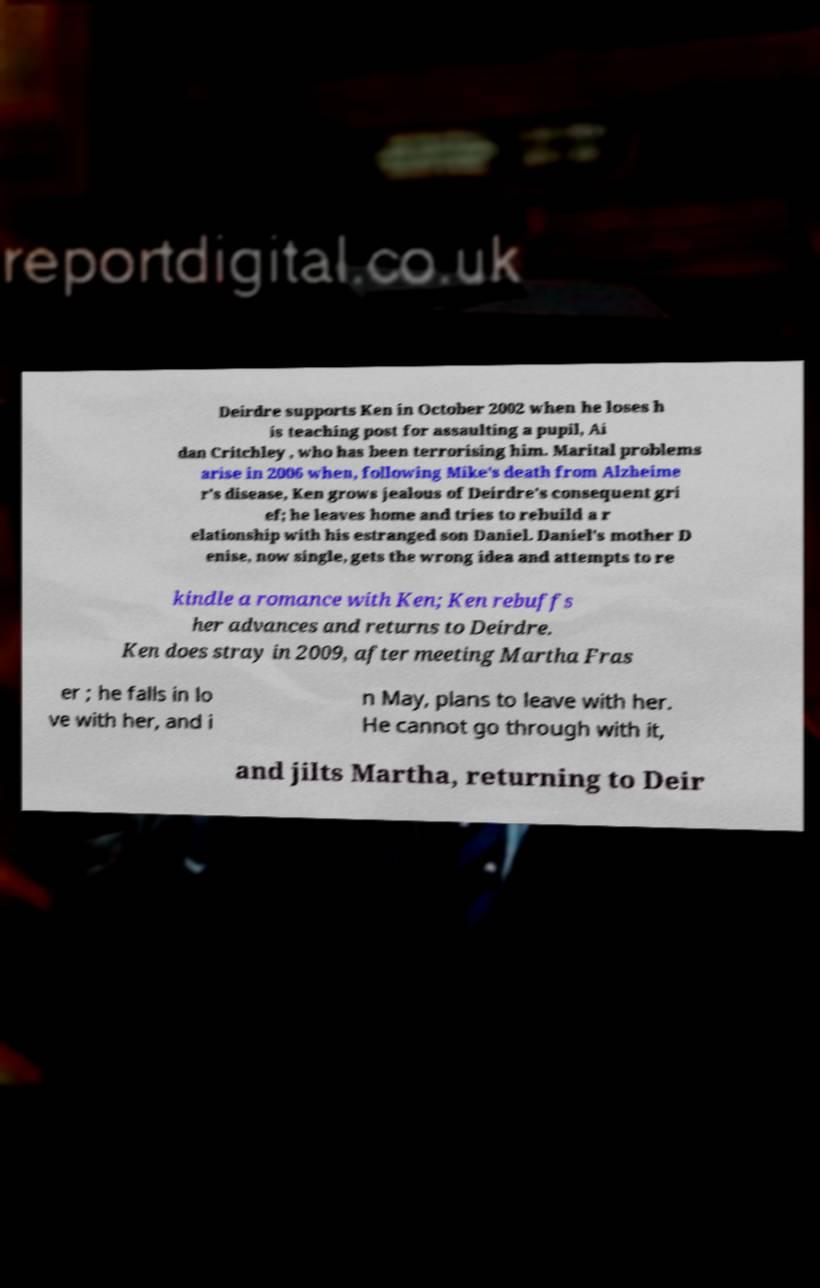Can you read and provide the text displayed in the image?This photo seems to have some interesting text. Can you extract and type it out for me? Deirdre supports Ken in October 2002 when he loses h is teaching post for assaulting a pupil, Ai dan Critchley , who has been terrorising him. Marital problems arise in 2006 when, following Mike's death from Alzheime r's disease, Ken grows jealous of Deirdre's consequent gri ef; he leaves home and tries to rebuild a r elationship with his estranged son Daniel. Daniel's mother D enise, now single, gets the wrong idea and attempts to re kindle a romance with Ken; Ken rebuffs her advances and returns to Deirdre. Ken does stray in 2009, after meeting Martha Fras er ; he falls in lo ve with her, and i n May, plans to leave with her. He cannot go through with it, and jilts Martha, returning to Deir 